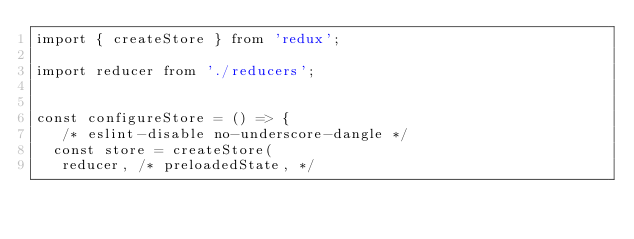<code> <loc_0><loc_0><loc_500><loc_500><_JavaScript_>import { createStore } from 'redux';

import reducer from './reducers';


const configureStore = () => {
   /* eslint-disable no-underscore-dangle */
  const store = createStore(
   reducer, /* preloadedState, */</code> 